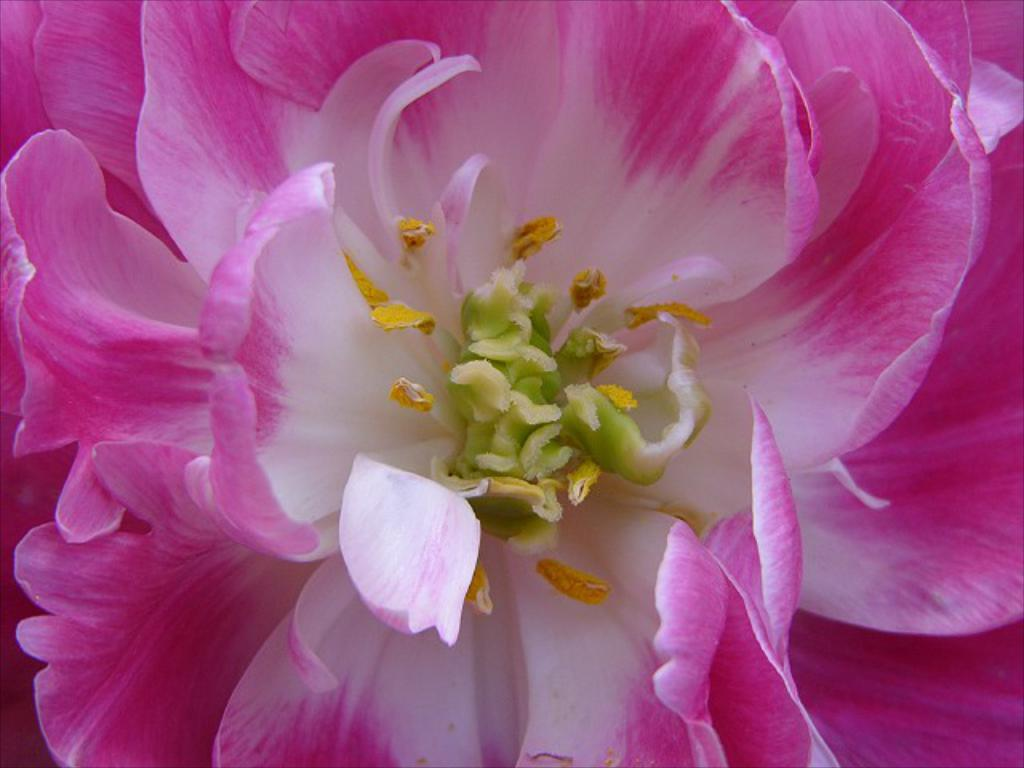What are the dominant colors in the image? The picture is mainly highlighted with pink and white flowers. Can you describe the flowers in the image? The flowers in the image are pink and white. Where is the toothbrush located in the image? There is no toothbrush present in the image; it features pink and white flowers. What type of cord can be seen connecting the flowers in the image? There is no cord connecting the flowers in the image; it only features pink and white flowers. 